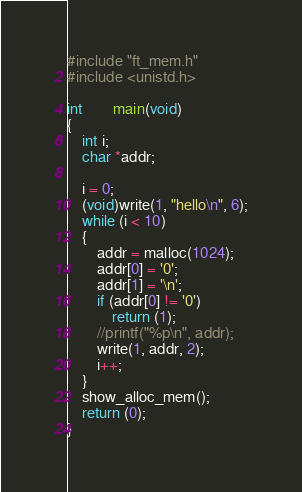<code> <loc_0><loc_0><loc_500><loc_500><_C_>#include "ft_mem.h"
#include <unistd.h>

int		main(void)
{
	int i;
	char *addr;

	i = 0;
	(void)write(1, "hello\n", 6);
	while (i < 10)
	{
		addr = malloc(1024);
		addr[0] = '0';
		addr[1] = '\n';
		if (addr[0] != '0')
			return (1);
		//printf("%p\n", addr);
		write(1, addr, 2);
		i++;
	}
	show_alloc_mem();
	return (0);
}
</code> 